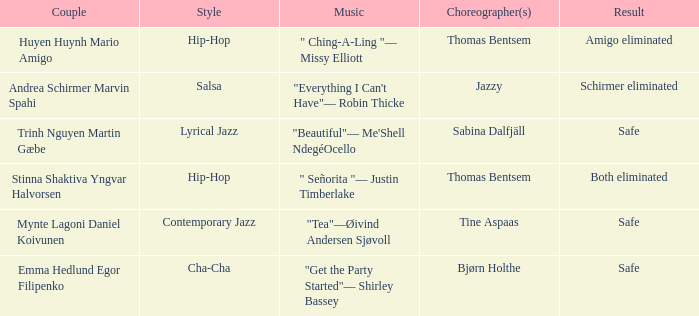What is the musical composition for choreographer sabina dalfjäll? "Beautiful"— Me'Shell NdegéOcello. 